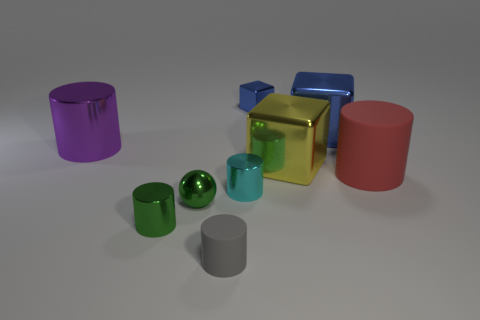There is another blue metallic object that is the same shape as the big blue metallic object; what size is it?
Your response must be concise. Small. What shape is the large metallic thing behind the big cylinder on the left side of the ball?
Keep it short and to the point. Cube. What number of purple things are large rubber cylinders or large metallic cylinders?
Give a very brief answer. 1. What is the color of the tiny shiny sphere?
Provide a succinct answer. Green. Do the cyan object and the purple cylinder have the same size?
Offer a terse response. No. Is the material of the tiny blue cube the same as the big cylinder to the right of the small green sphere?
Keep it short and to the point. No. Is the color of the tiny metallic cylinder that is on the left side of the gray matte thing the same as the small metallic sphere?
Provide a succinct answer. Yes. What number of objects are both behind the red rubber cylinder and left of the yellow block?
Give a very brief answer. 2. What number of other things are there of the same material as the big purple thing
Ensure brevity in your answer.  6. Is the material of the tiny cylinder that is to the right of the tiny gray rubber thing the same as the gray object?
Your answer should be compact. No. 